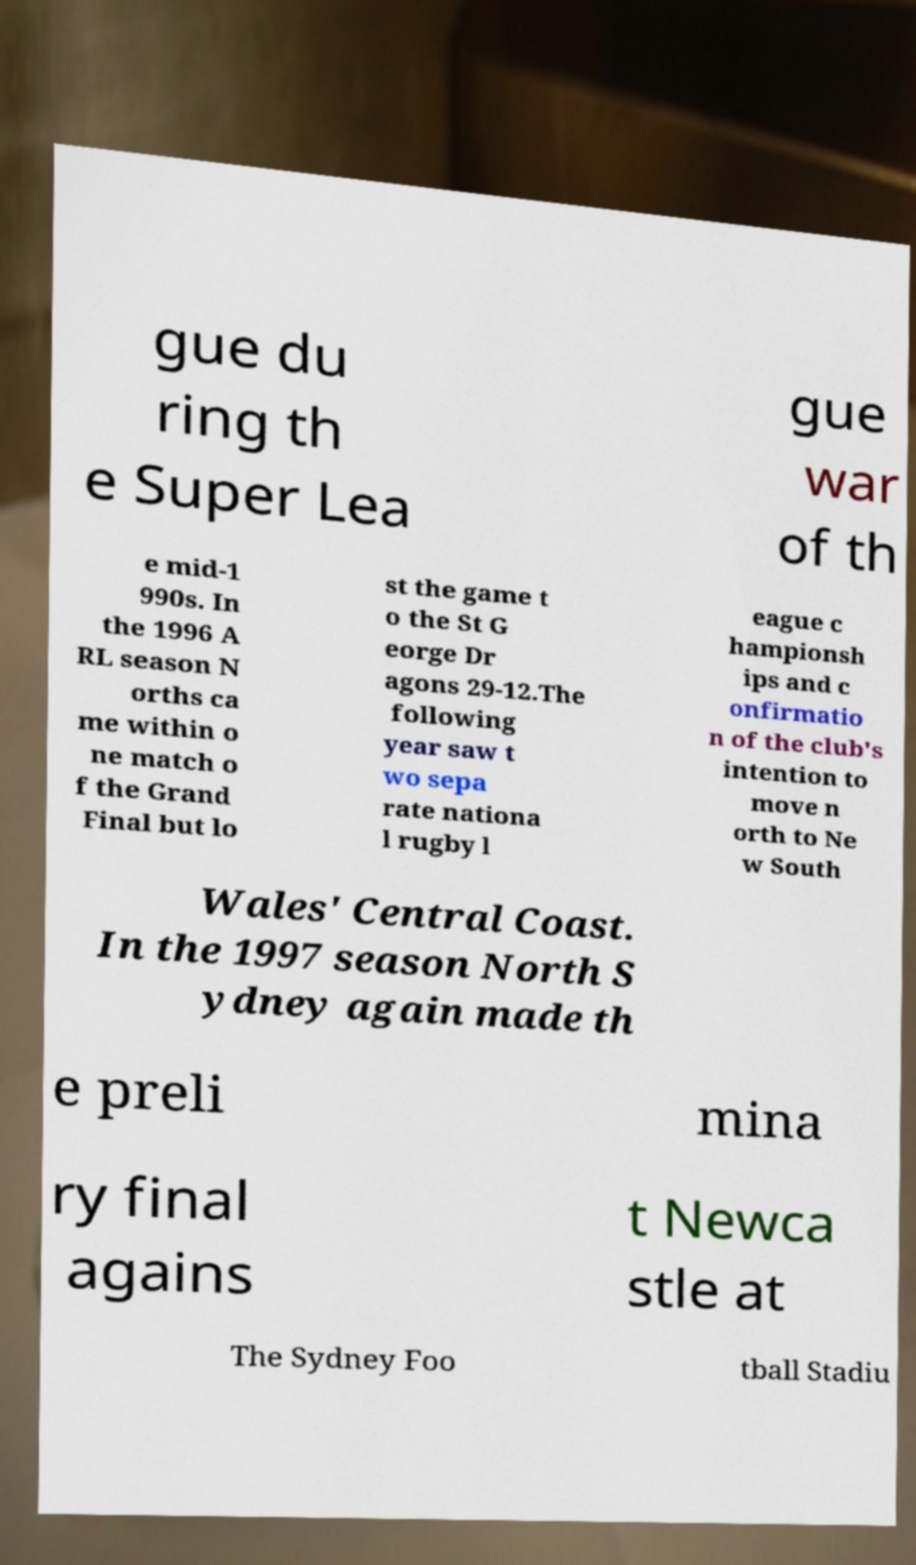For documentation purposes, I need the text within this image transcribed. Could you provide that? gue du ring th e Super Lea gue war of th e mid-1 990s. In the 1996 A RL season N orths ca me within o ne match o f the Grand Final but lo st the game t o the St G eorge Dr agons 29-12.The following year saw t wo sepa rate nationa l rugby l eague c hampionsh ips and c onfirmatio n of the club's intention to move n orth to Ne w South Wales' Central Coast. In the 1997 season North S ydney again made th e preli mina ry final agains t Newca stle at The Sydney Foo tball Stadiu 